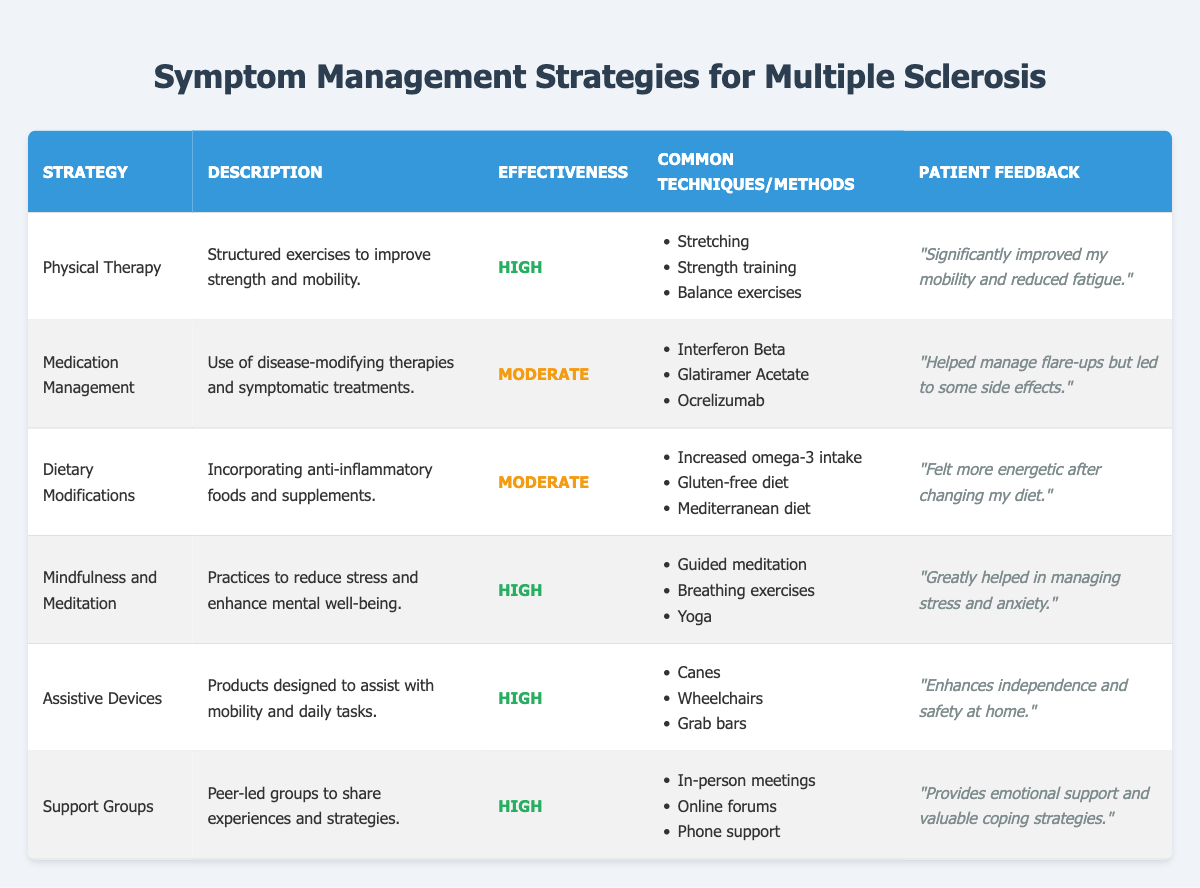What is the effectiveness rating for Mindfulness and Meditation? The effectiveness rating for Mindfulness and Meditation is listed in the table under the "Effectiveness" column. It is marked as "High."
Answer: High Which strategies have an effectiveness rating of Moderate? To find the strategies with a Moderate effectiveness rating, we can look at the "Effectiveness" column and identify the strategies that are marked with "Moderate." The strategies are Medication Management and Dietary Modifications.
Answer: Medication Management, Dietary Modifications What are the common techniques used in Physical Therapy? The common techniques for Physical Therapy are listed in the table under the "Common Techniques/Methods" column. These include Stretching, Strength training, and Balance exercises.
Answer: Stretching, Strength training, Balance exercises Is there any strategy with a "High" effectiveness that also involves dietary changes? In the table, none of the strategies with a "High" effectiveness rating involve dietary changes. The strategies that are marked as "High" are Physical Therapy, Mindfulness and Meditation, Assistive Devices, and Support Groups. None of these mention dietary modifications.
Answer: No Which symptom management strategy received the most positive patient feedback? To determine which strategy received the most positive feedback, we can look at the patient feedback for each strategy in the "Patient Feedback" column. The feedback for Mindfulness and Meditation states, "Greatly helped in managing stress and anxiety," which implies a strong positive impact on the patient's well-being.
Answer: Mindfulness and Meditation What percentage of strategies reported a "High" effectiveness rating? Out of the total 6 strategies listed in the table, 4 strategies have a "High" effectiveness rating (Physical Therapy, Mindfulness and Meditation, Assistive Devices, Support Groups). To find the percentage, we calculate (4/6) * 100 = 66.67%.
Answer: Approximately 66.67% Are Assistive Devices one of the methods recommended for managing symptoms of multiple sclerosis? Looking at the table, Assistive Devices is listed as a strategy under the "Symptom Management Strategies" section, indicating that it is indeed recommended for managing symptoms.
Answer: Yes What are some common medications listed under Medication Management? The common medications used in Medication Management are listed in the "Common Techniques/Methods" column. The table mentions Interferon Beta, Glatiramer Acetate, and Ocrelizumab as examples.
Answer: Interferon Beta, Glatiramer Acetate, Ocrelizumab Which strategy combines physical activity and therapy to improve strength and mobility? Physical Therapy is identified in the table as the strategy that combines physical activities and structured exercises specifically aimed at improving strength and mobility.
Answer: Physical Therapy 